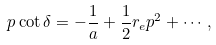<formula> <loc_0><loc_0><loc_500><loc_500>p \cot \delta = - \frac { 1 } { a } + \frac { 1 } { 2 } r _ { e } p ^ { 2 } + \cdots ,</formula> 